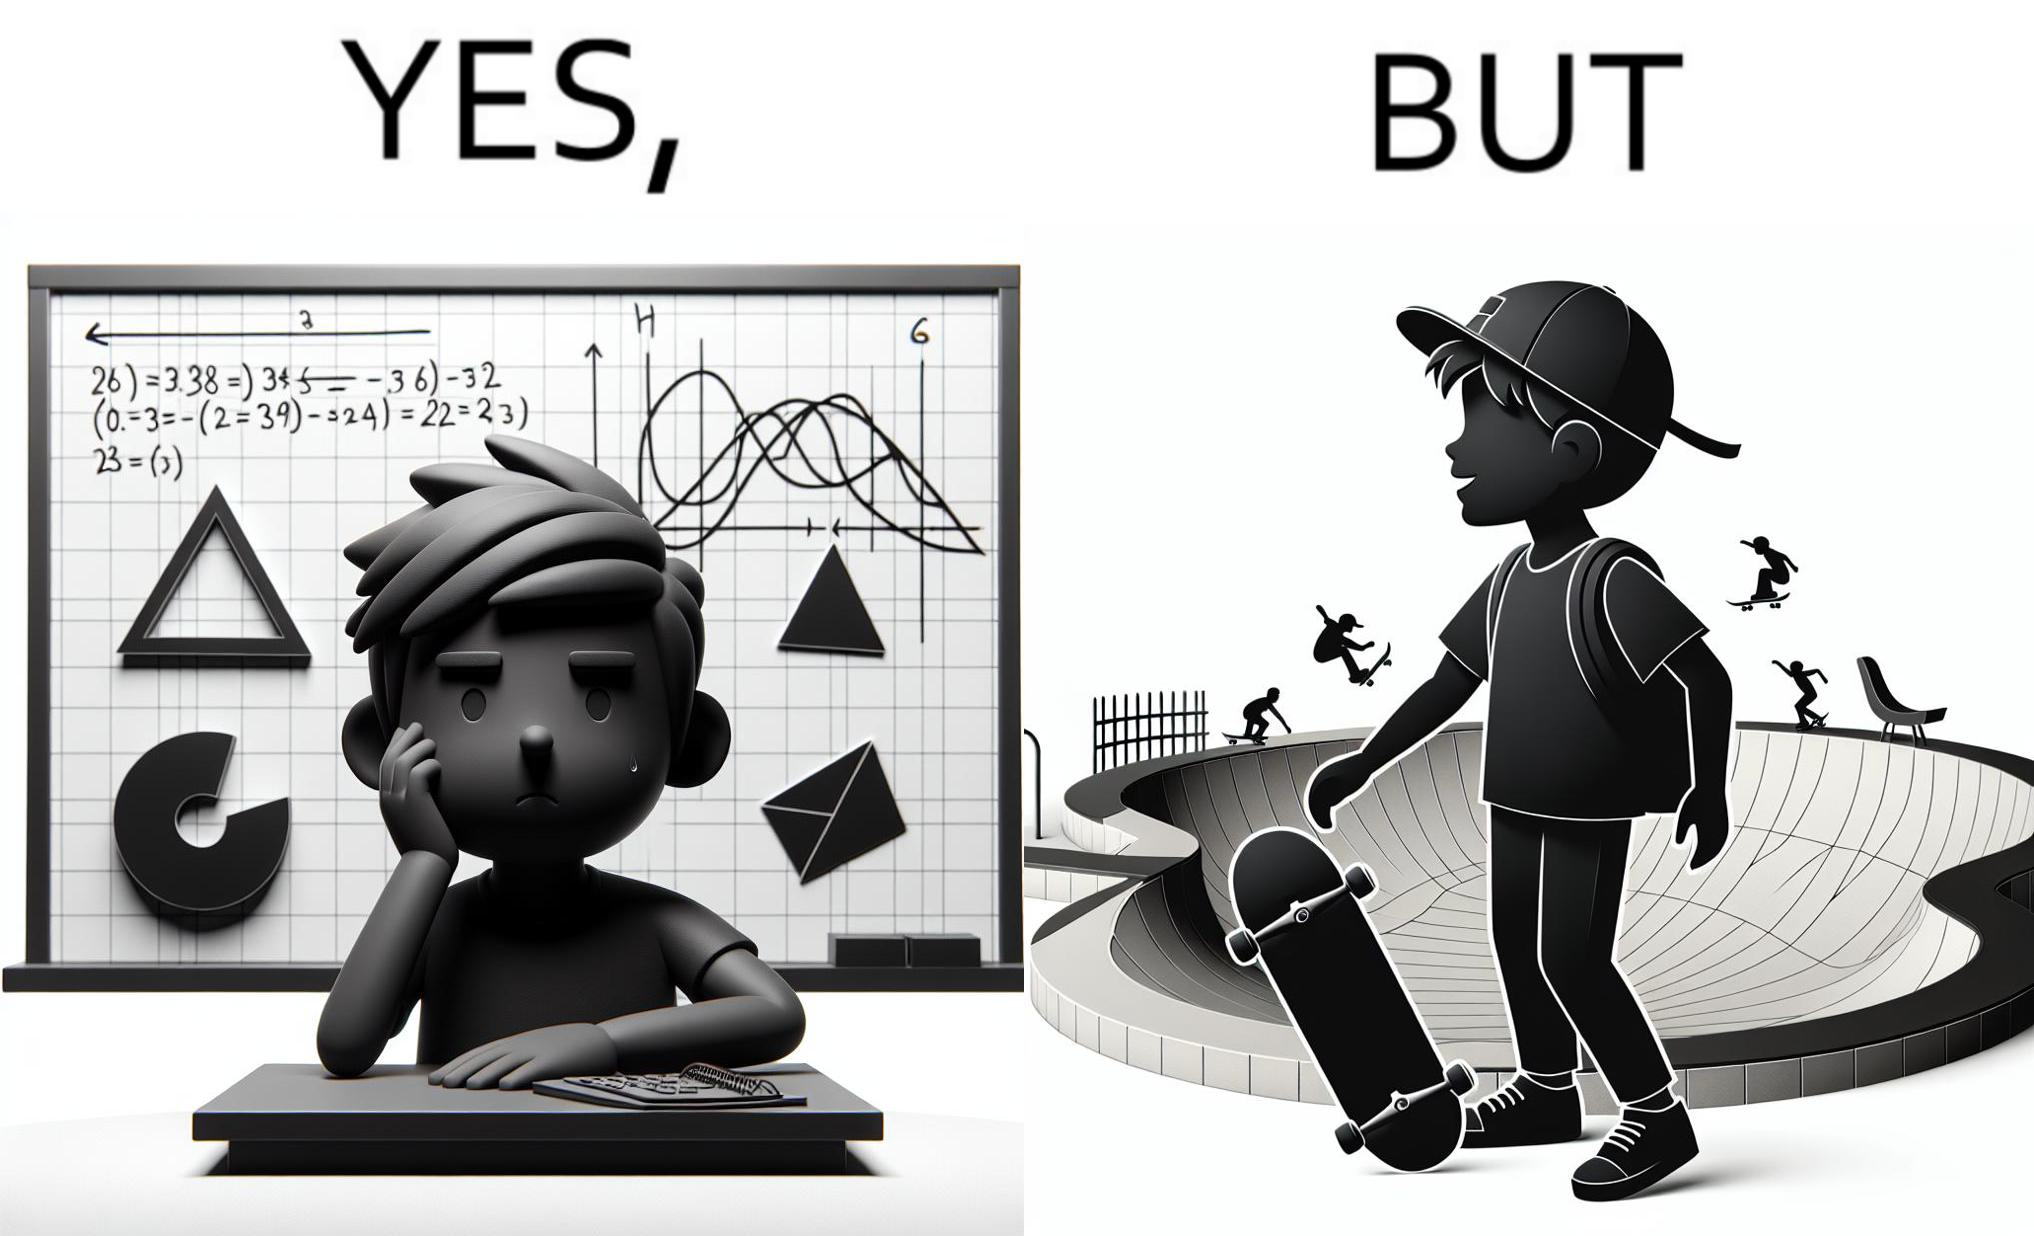Describe what you see in this image. The image is ironical beaucse while the boy does not enjoy studying mathematics and different geometric shapes like semi circle and trapezoid and graphs of trigonometric equations like that of a sine wave, he enjoys skateboarding on surfaces and bowls that are built based on the said geometric shapes and graphs of trigonometric equations. 